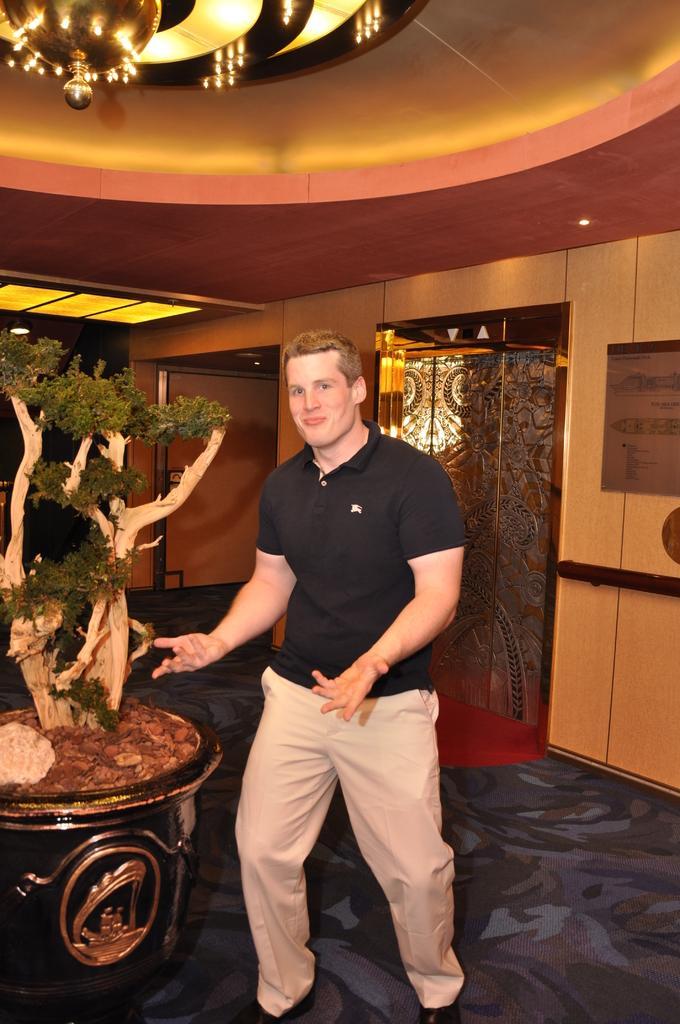How would you summarize this image in a sentence or two? In this image I can see a man standing, he is wearing a black t shirt and a pant. There is a plant on the left. There is a chandelier at the top and a door at the back. 